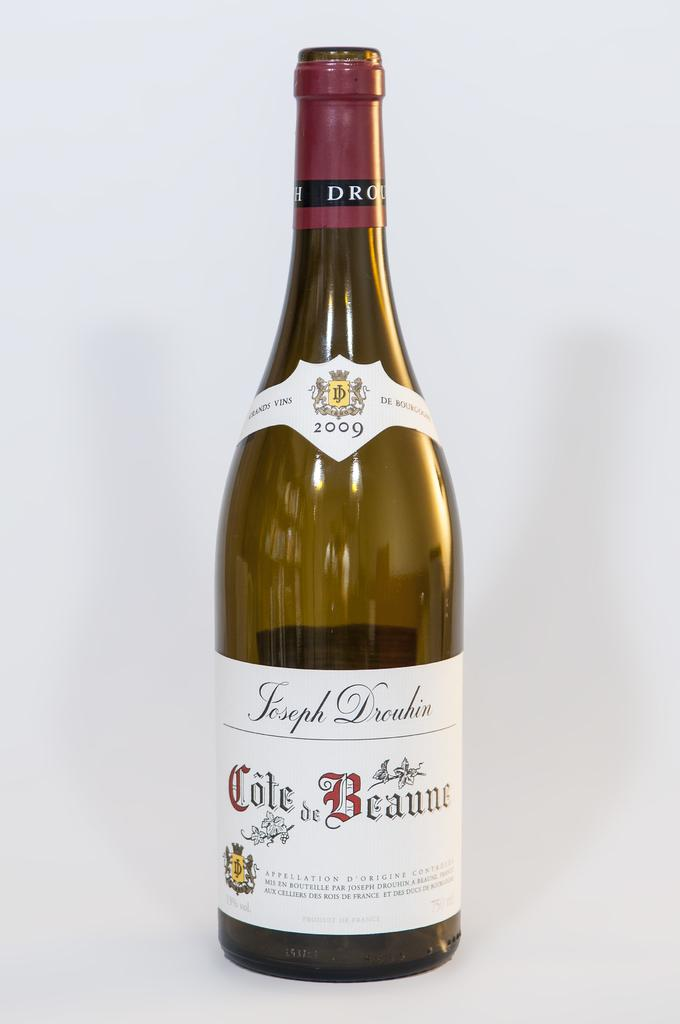<image>
Summarize the visual content of the image. Bottle of cote de Beaune wine  that is empty 